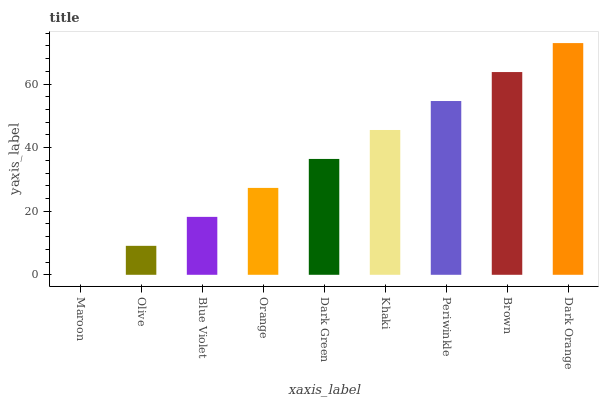Is Maroon the minimum?
Answer yes or no. Yes. Is Dark Orange the maximum?
Answer yes or no. Yes. Is Olive the minimum?
Answer yes or no. No. Is Olive the maximum?
Answer yes or no. No. Is Olive greater than Maroon?
Answer yes or no. Yes. Is Maroon less than Olive?
Answer yes or no. Yes. Is Maroon greater than Olive?
Answer yes or no. No. Is Olive less than Maroon?
Answer yes or no. No. Is Dark Green the high median?
Answer yes or no. Yes. Is Dark Green the low median?
Answer yes or no. Yes. Is Periwinkle the high median?
Answer yes or no. No. Is Periwinkle the low median?
Answer yes or no. No. 